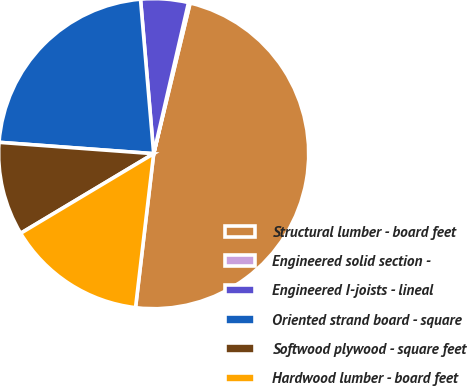<chart> <loc_0><loc_0><loc_500><loc_500><pie_chart><fcel>Structural lumber - board feet<fcel>Engineered solid section -<fcel>Engineered I-joists - lineal<fcel>Oriented strand board - square<fcel>Softwood plywood - square feet<fcel>Hardwood lumber - board feet<nl><fcel>48.09%<fcel>0.17%<fcel>4.96%<fcel>22.48%<fcel>9.75%<fcel>14.55%<nl></chart> 